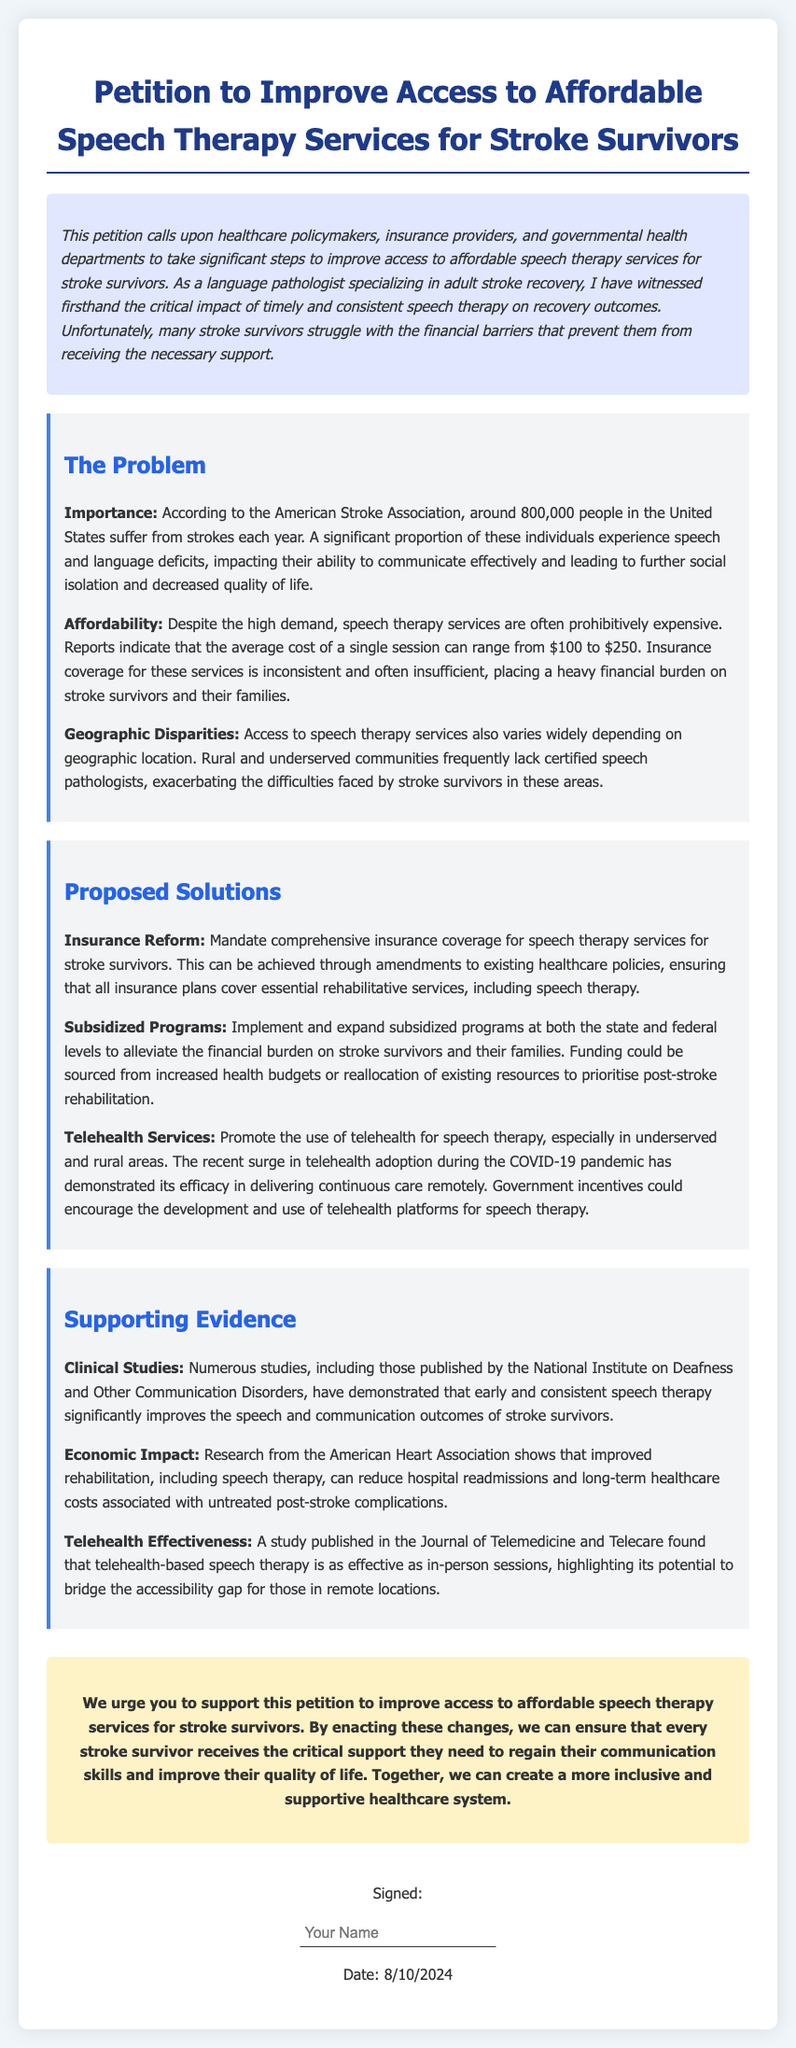What is the title of the petition? The title of the petition is explicitly stated at the beginning of the document.
Answer: Petition to Improve Access to Affordable Speech Therapy Services for Stroke Survivors How many people in the United States suffer from strokes each year? The document mentions that around 800,000 people in the United States suffer from strokes each year.
Answer: 800,000 What is the average cost range of a single speech therapy session? The document provides specific figures regarding the cost of speech therapy sessions.
Answer: $100 to $250 What is one proposed solution mentioned in the petition? The document lists several solutions aimed at addressing the identified problems.
Answer: Insurance Reform What kind of studies support the need for speech therapy? The document references specific types of studies that provide evidence for the necessity of speech therapy.
Answer: Clinical Studies What has demonstrated the effectiveness of telehealth services for speech therapy? The document cites a specific study that supports the use of telehealth for speech therapy.
Answer: A study published in the Journal of Telemedicine and Telecare What type of burden does the petition highlight for stroke survivors? The document specifies a type of challenge that stroke survivors face regarding therapy access.
Answer: Financial burden What is the key focus of the petition? The main purpose of the petition is clearly stated in the introductory paragraph.
Answer: Improve access to affordable speech therapy services for stroke survivors 